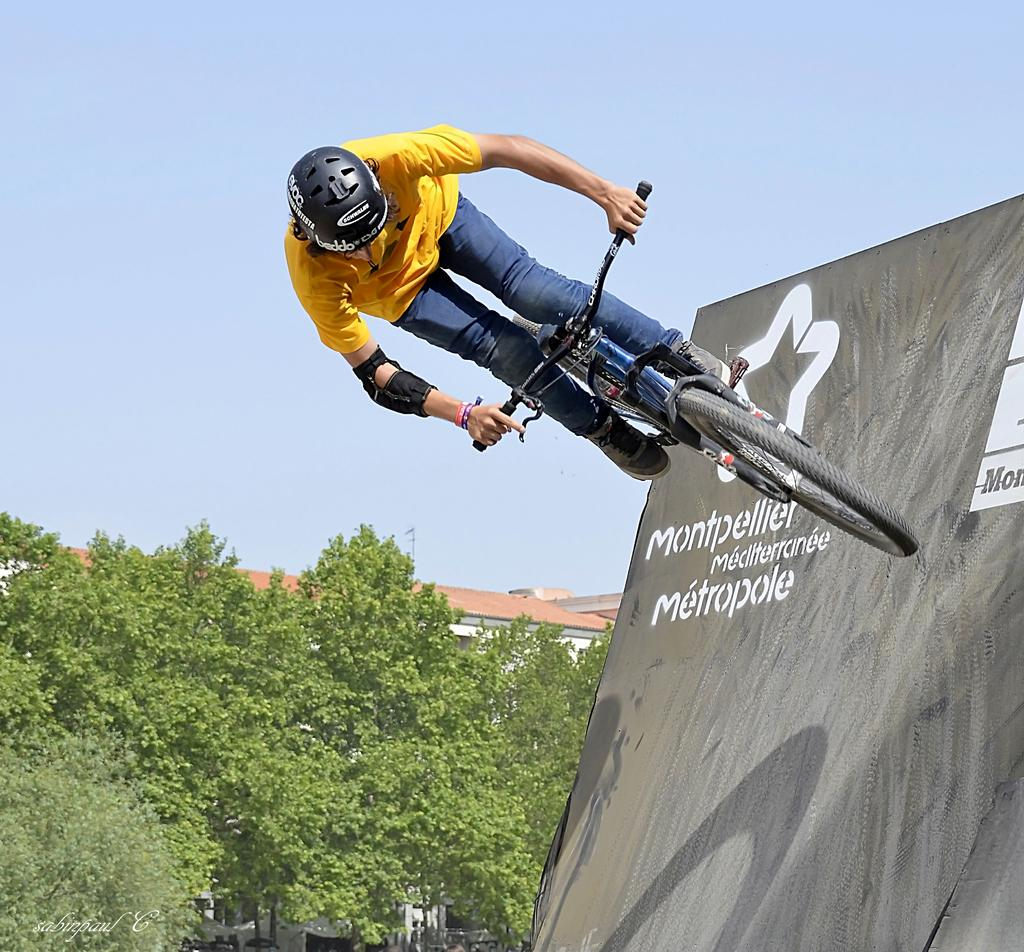What is the main subject of the image? There is a person in the image. What is the person wearing? The person is wearing a yellow and blue dress. What is the person doing in the image? The person is on a bicycle. What can be seen in the background of the image? There are trees, buildings, and a blue sky in the background of the image. What type of structure is present in the image? There is a rink board in the image. Where is the lunchroom located in the image? There is no lunchroom present in the image. What type of coach is visible in the image? There is no coach present in the image. 